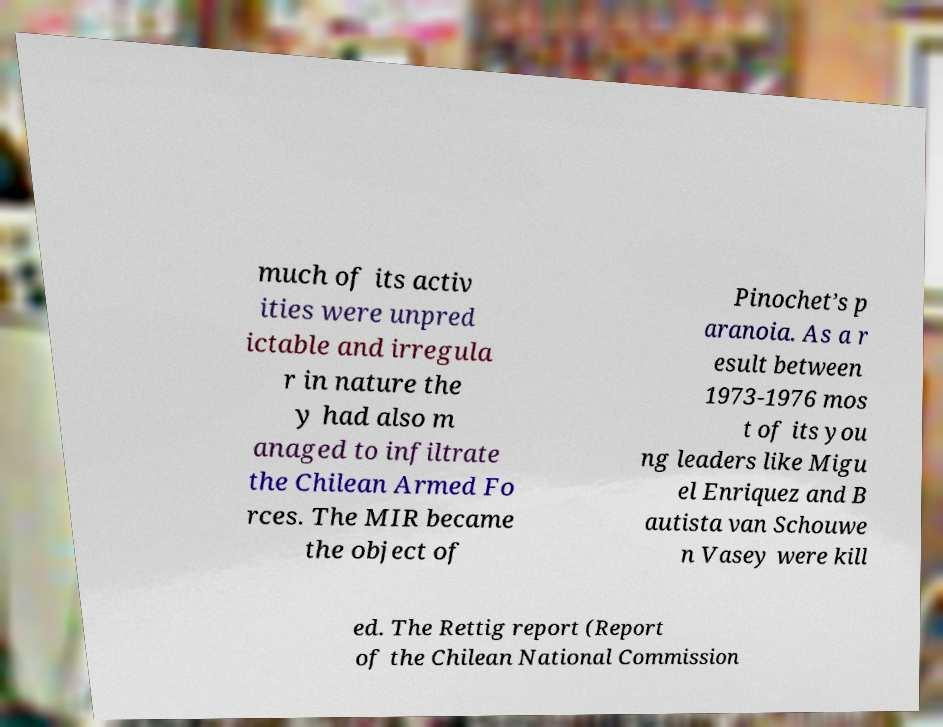I need the written content from this picture converted into text. Can you do that? much of its activ ities were unpred ictable and irregula r in nature the y had also m anaged to infiltrate the Chilean Armed Fo rces. The MIR became the object of Pinochet’s p aranoia. As a r esult between 1973-1976 mos t of its you ng leaders like Migu el Enriquez and B autista van Schouwe n Vasey were kill ed. The Rettig report (Report of the Chilean National Commission 